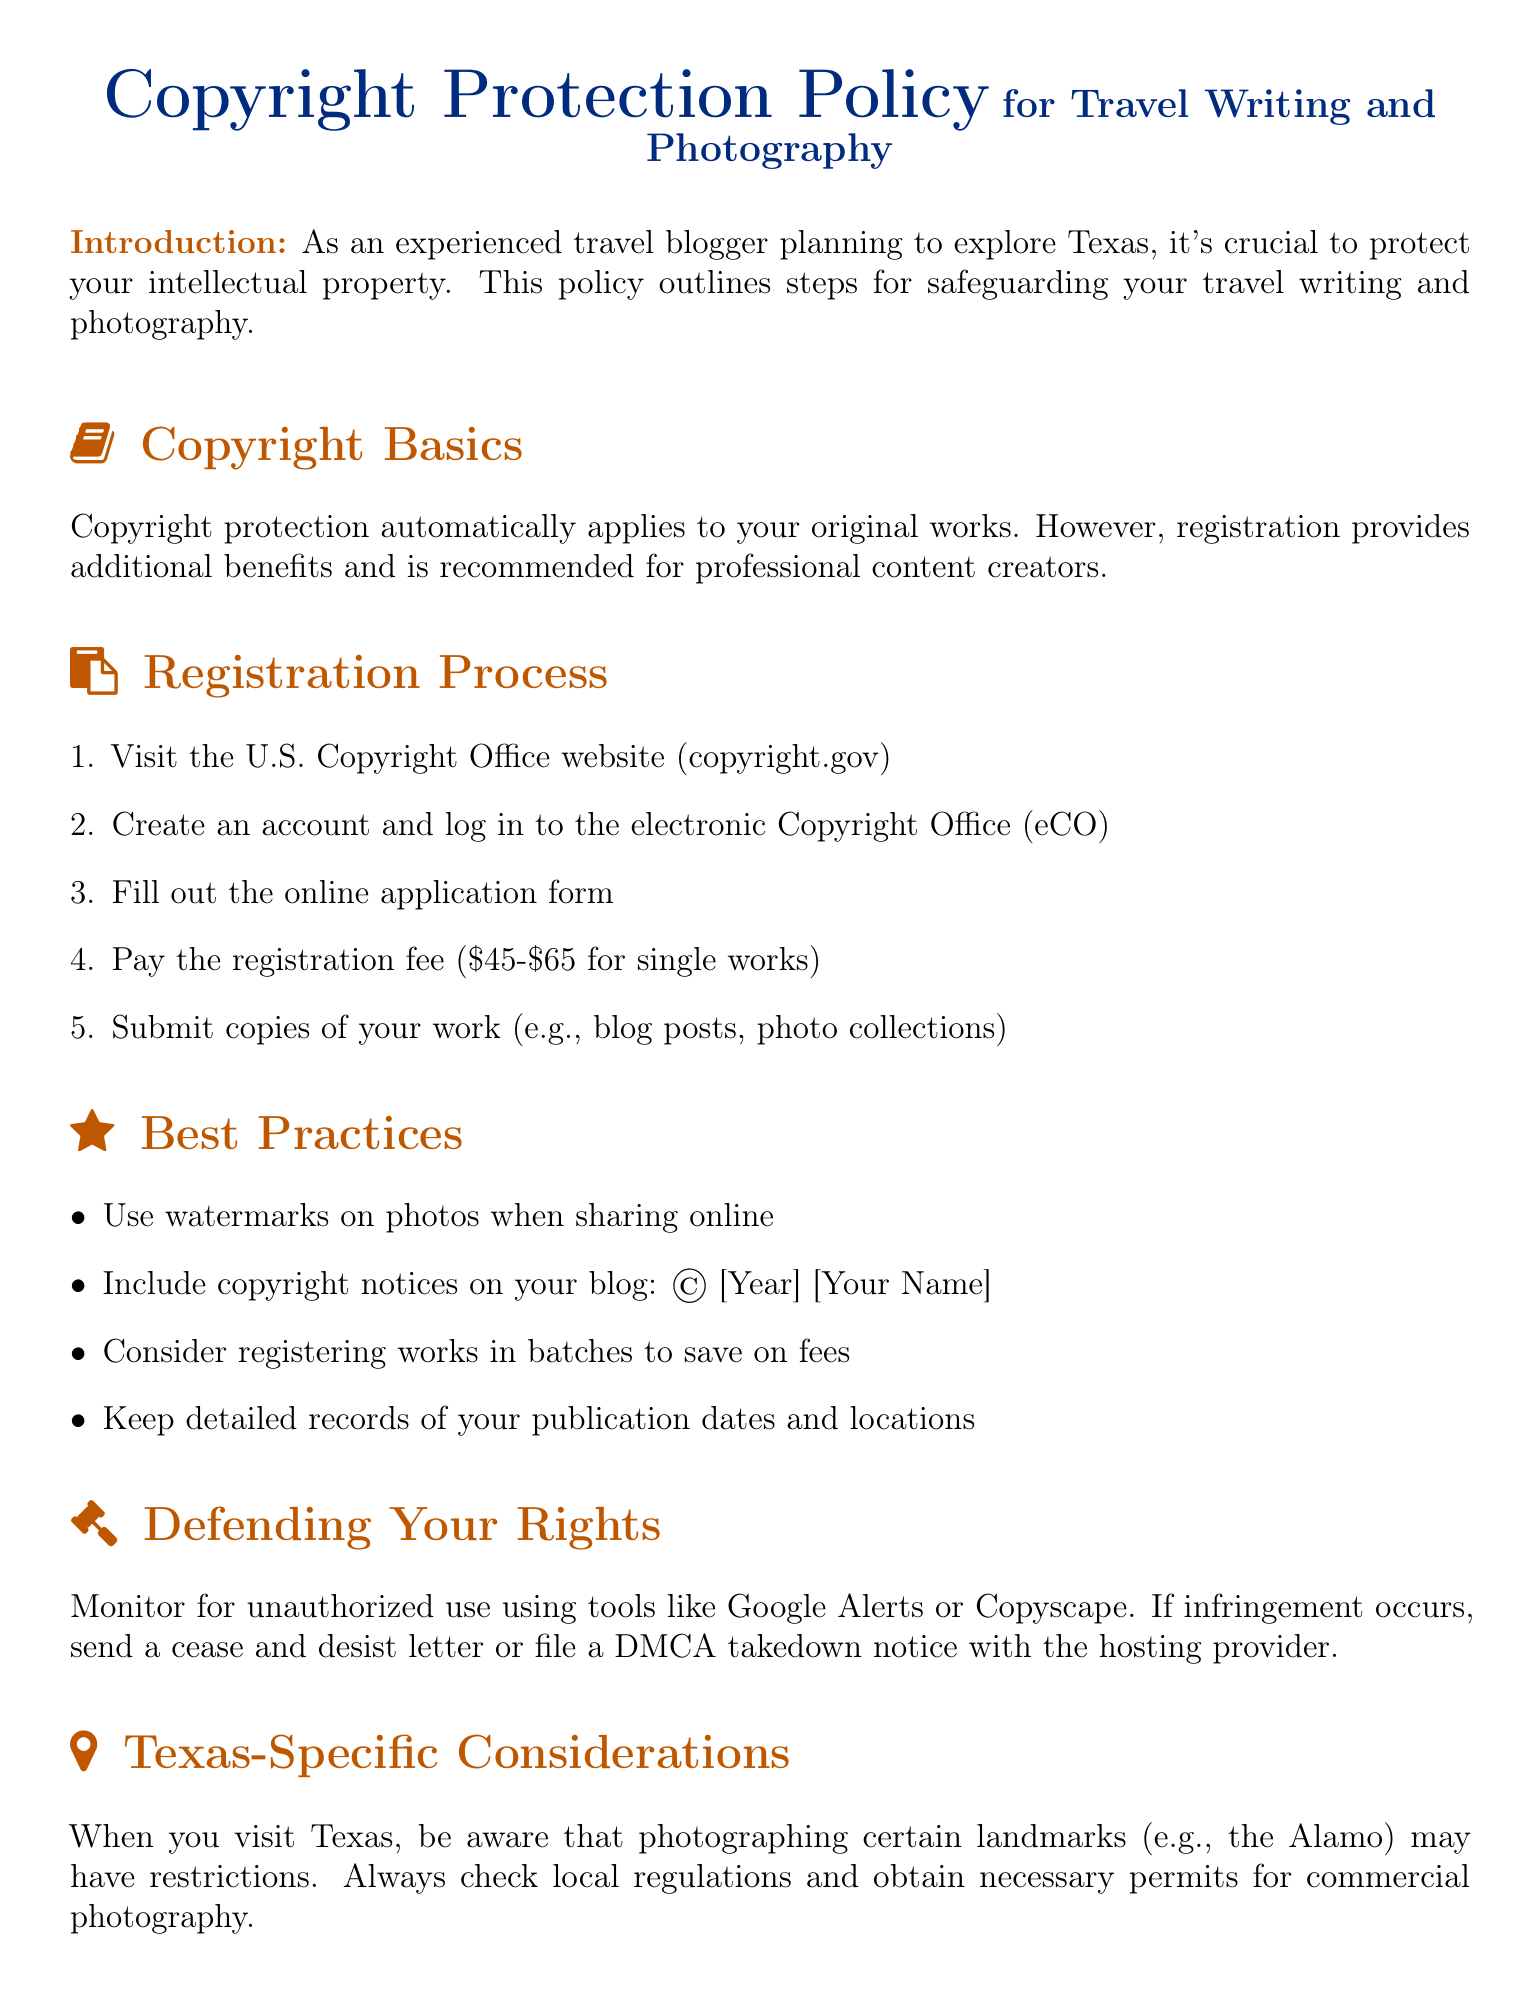What is the recommended registration fee range for single works? The document specifies the fee range for registering single works is between 45 and 65 dollars.
Answer: 45-65 dollars What is the first step in the registration process? The first step as outlined in the document is to visit the U.S. Copyright Office website.
Answer: Visit the U.S. Copyright Office website What should you include in your copyright notice? According to the document, the copyright notice should include the year and your name.
Answer: © [Year] [Your Name] What tool is mentioned for monitoring unauthorized use of your work? The document mentions using Google Alerts or Copyscape as tools for monitoring.
Answer: Google Alerts or Copyscape How many steps are in the registration process? The document lists five distinct steps involved in the registration process.
Answer: 5 What should be done if infringement occurs? The document suggests sending a cease and desist letter or filing a DMCA takedown notice.
Answer: Send a cease and desist letter or file a DMCA takedown notice What is a best practice for sharing photos online? The document advises using watermarks on photos when sharing them online.
Answer: Use watermarks What specific consideration is mentioned regarding Texas photography? The document notes that photographing certain landmarks may have restrictions in Texas.
Answer: Restrictions on photographing certain landmarks What should be maintained to protect publication rights? The document states that keeping detailed records of publication dates and locations is important.
Answer: Detailed records of publication dates and locations 